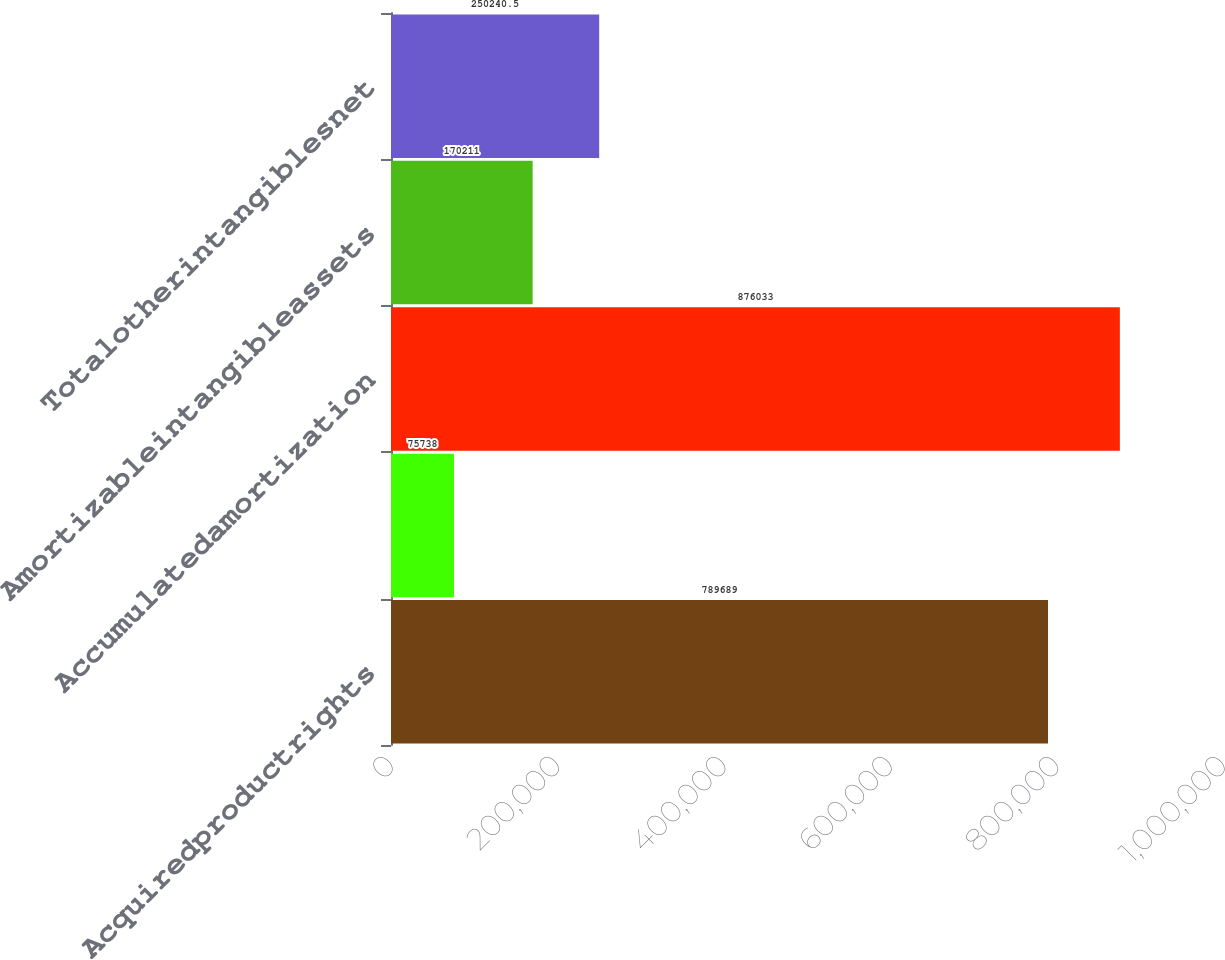Convert chart to OTSL. <chart><loc_0><loc_0><loc_500><loc_500><bar_chart><fcel>Acquiredproductrights<fcel>Unnamed: 1<fcel>Accumulatedamortization<fcel>Amortizableintangibleassets<fcel>Totalotherintangiblesnet<nl><fcel>789689<fcel>75738<fcel>876033<fcel>170211<fcel>250240<nl></chart> 